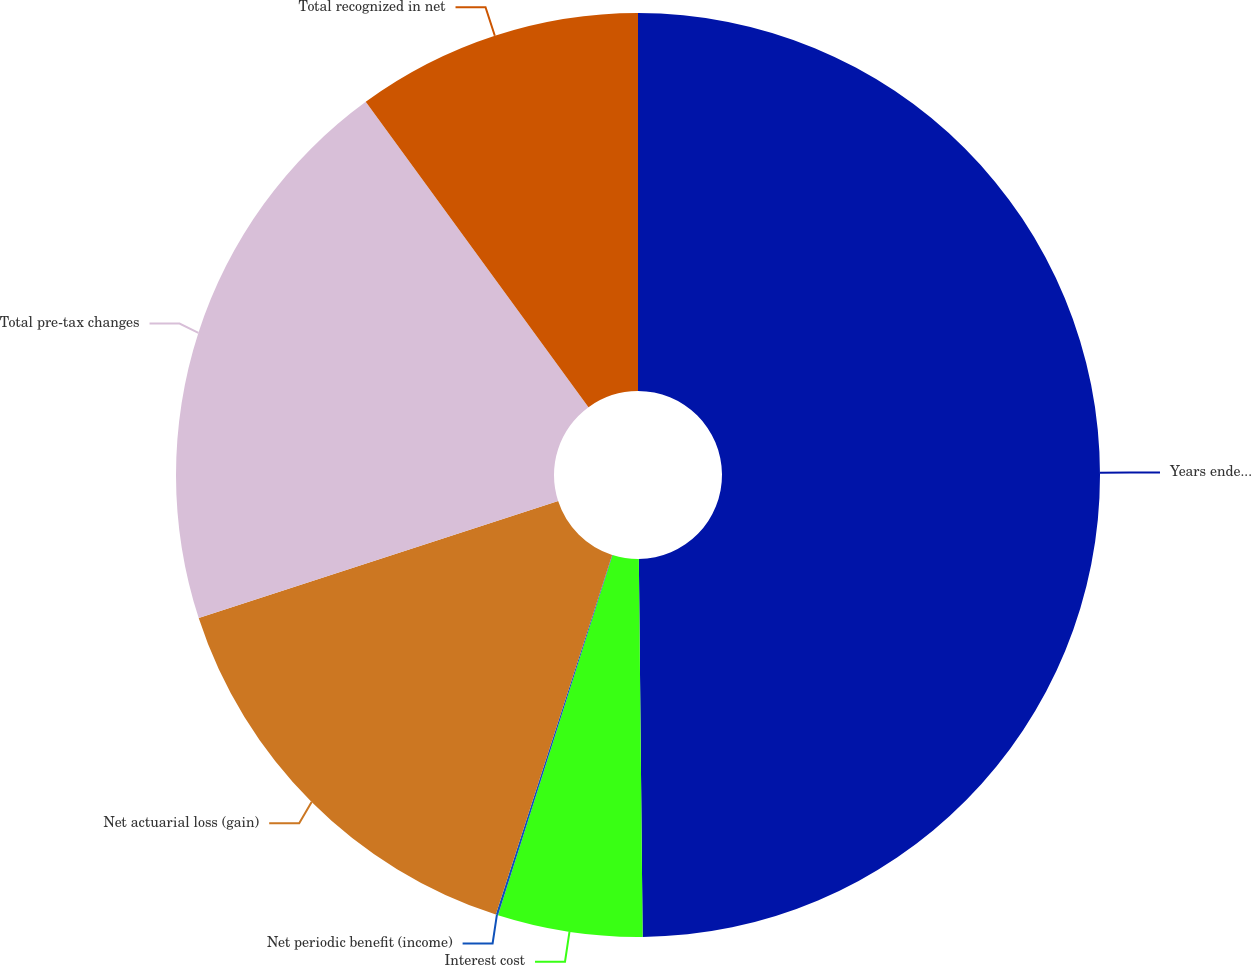<chart> <loc_0><loc_0><loc_500><loc_500><pie_chart><fcel>Years ended December 31 (in<fcel>Interest cost<fcel>Net periodic benefit (income)<fcel>Net actuarial loss (gain)<fcel>Total pre-tax changes<fcel>Total recognized in net<nl><fcel>49.84%<fcel>5.06%<fcel>0.08%<fcel>15.01%<fcel>19.98%<fcel>10.03%<nl></chart> 